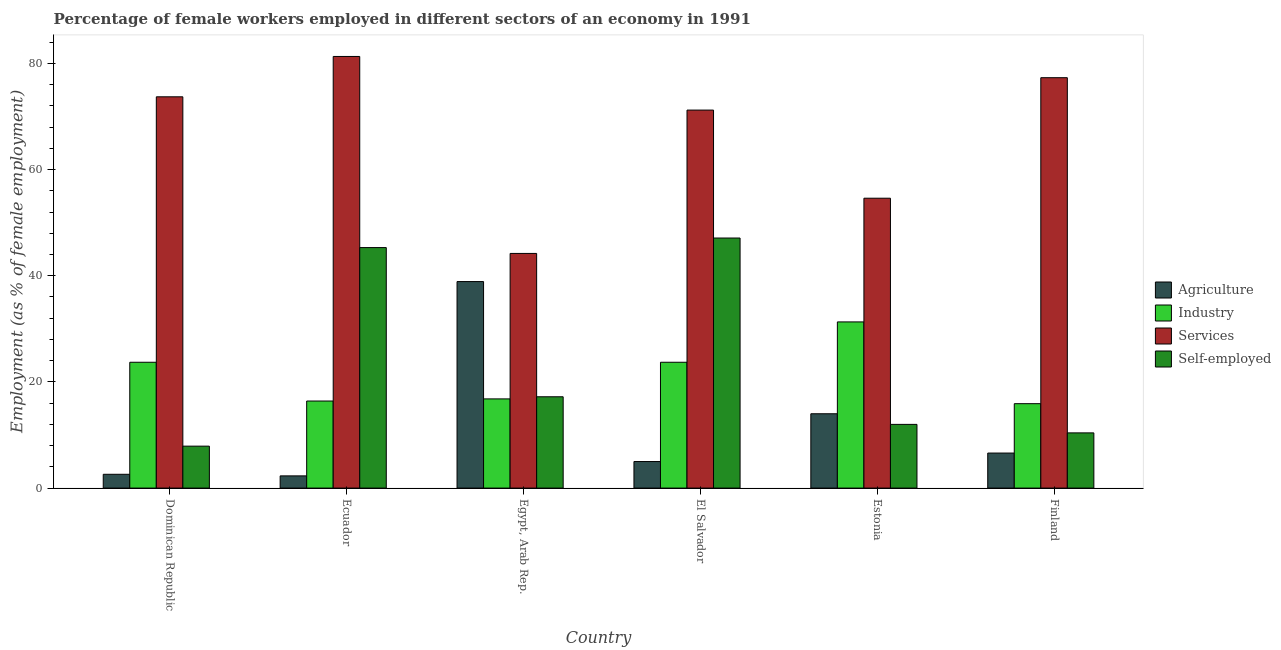How many different coloured bars are there?
Your answer should be compact. 4. How many groups of bars are there?
Offer a very short reply. 6. How many bars are there on the 1st tick from the right?
Ensure brevity in your answer.  4. What is the label of the 3rd group of bars from the left?
Your answer should be very brief. Egypt, Arab Rep. What is the percentage of female workers in services in El Salvador?
Your answer should be compact. 71.2. Across all countries, what is the maximum percentage of self employed female workers?
Provide a short and direct response. 47.1. Across all countries, what is the minimum percentage of female workers in industry?
Your answer should be compact. 15.9. In which country was the percentage of female workers in services maximum?
Offer a terse response. Ecuador. In which country was the percentage of female workers in services minimum?
Your answer should be very brief. Egypt, Arab Rep. What is the total percentage of female workers in services in the graph?
Provide a short and direct response. 402.3. What is the difference between the percentage of female workers in services in Ecuador and that in Finland?
Offer a terse response. 4. What is the difference between the percentage of self employed female workers in Estonia and the percentage of female workers in industry in Egypt, Arab Rep.?
Provide a succinct answer. -4.8. What is the average percentage of female workers in services per country?
Offer a terse response. 67.05. What is the difference between the percentage of female workers in services and percentage of female workers in agriculture in El Salvador?
Your answer should be very brief. 66.2. In how many countries, is the percentage of female workers in services greater than 72 %?
Offer a very short reply. 3. What is the ratio of the percentage of self employed female workers in Estonia to that in Finland?
Your answer should be very brief. 1.15. Is the percentage of female workers in agriculture in Egypt, Arab Rep. less than that in El Salvador?
Keep it short and to the point. No. Is the difference between the percentage of female workers in agriculture in Ecuador and Finland greater than the difference between the percentage of female workers in services in Ecuador and Finland?
Provide a short and direct response. No. What is the difference between the highest and the lowest percentage of self employed female workers?
Ensure brevity in your answer.  39.2. In how many countries, is the percentage of female workers in industry greater than the average percentage of female workers in industry taken over all countries?
Offer a very short reply. 3. What does the 3rd bar from the left in Dominican Republic represents?
Provide a succinct answer. Services. What does the 2nd bar from the right in Estonia represents?
Offer a terse response. Services. Is it the case that in every country, the sum of the percentage of female workers in agriculture and percentage of female workers in industry is greater than the percentage of female workers in services?
Provide a short and direct response. No. How many bars are there?
Provide a short and direct response. 24. Are all the bars in the graph horizontal?
Give a very brief answer. No. Does the graph contain grids?
Your response must be concise. No. Where does the legend appear in the graph?
Give a very brief answer. Center right. What is the title of the graph?
Offer a terse response. Percentage of female workers employed in different sectors of an economy in 1991. Does "Switzerland" appear as one of the legend labels in the graph?
Make the answer very short. No. What is the label or title of the X-axis?
Your response must be concise. Country. What is the label or title of the Y-axis?
Your answer should be very brief. Employment (as % of female employment). What is the Employment (as % of female employment) of Agriculture in Dominican Republic?
Make the answer very short. 2.6. What is the Employment (as % of female employment) in Industry in Dominican Republic?
Give a very brief answer. 23.7. What is the Employment (as % of female employment) of Services in Dominican Republic?
Provide a short and direct response. 73.7. What is the Employment (as % of female employment) of Self-employed in Dominican Republic?
Offer a terse response. 7.9. What is the Employment (as % of female employment) of Agriculture in Ecuador?
Your answer should be compact. 2.3. What is the Employment (as % of female employment) in Industry in Ecuador?
Offer a terse response. 16.4. What is the Employment (as % of female employment) in Services in Ecuador?
Your answer should be compact. 81.3. What is the Employment (as % of female employment) in Self-employed in Ecuador?
Offer a very short reply. 45.3. What is the Employment (as % of female employment) of Agriculture in Egypt, Arab Rep.?
Ensure brevity in your answer.  38.9. What is the Employment (as % of female employment) of Industry in Egypt, Arab Rep.?
Provide a short and direct response. 16.8. What is the Employment (as % of female employment) of Services in Egypt, Arab Rep.?
Your response must be concise. 44.2. What is the Employment (as % of female employment) of Self-employed in Egypt, Arab Rep.?
Keep it short and to the point. 17.2. What is the Employment (as % of female employment) of Industry in El Salvador?
Give a very brief answer. 23.7. What is the Employment (as % of female employment) in Services in El Salvador?
Your answer should be very brief. 71.2. What is the Employment (as % of female employment) of Self-employed in El Salvador?
Give a very brief answer. 47.1. What is the Employment (as % of female employment) of Industry in Estonia?
Provide a short and direct response. 31.3. What is the Employment (as % of female employment) in Services in Estonia?
Provide a short and direct response. 54.6. What is the Employment (as % of female employment) in Agriculture in Finland?
Keep it short and to the point. 6.6. What is the Employment (as % of female employment) in Industry in Finland?
Keep it short and to the point. 15.9. What is the Employment (as % of female employment) in Services in Finland?
Make the answer very short. 77.3. What is the Employment (as % of female employment) in Self-employed in Finland?
Provide a succinct answer. 10.4. Across all countries, what is the maximum Employment (as % of female employment) of Agriculture?
Ensure brevity in your answer.  38.9. Across all countries, what is the maximum Employment (as % of female employment) in Industry?
Ensure brevity in your answer.  31.3. Across all countries, what is the maximum Employment (as % of female employment) in Services?
Offer a terse response. 81.3. Across all countries, what is the maximum Employment (as % of female employment) in Self-employed?
Offer a terse response. 47.1. Across all countries, what is the minimum Employment (as % of female employment) in Agriculture?
Provide a succinct answer. 2.3. Across all countries, what is the minimum Employment (as % of female employment) in Industry?
Your answer should be very brief. 15.9. Across all countries, what is the minimum Employment (as % of female employment) in Services?
Your answer should be compact. 44.2. Across all countries, what is the minimum Employment (as % of female employment) of Self-employed?
Provide a short and direct response. 7.9. What is the total Employment (as % of female employment) of Agriculture in the graph?
Your answer should be compact. 69.4. What is the total Employment (as % of female employment) in Industry in the graph?
Provide a short and direct response. 127.8. What is the total Employment (as % of female employment) in Services in the graph?
Your response must be concise. 402.3. What is the total Employment (as % of female employment) of Self-employed in the graph?
Offer a terse response. 139.9. What is the difference between the Employment (as % of female employment) in Self-employed in Dominican Republic and that in Ecuador?
Your answer should be very brief. -37.4. What is the difference between the Employment (as % of female employment) in Agriculture in Dominican Republic and that in Egypt, Arab Rep.?
Your answer should be compact. -36.3. What is the difference between the Employment (as % of female employment) of Services in Dominican Republic and that in Egypt, Arab Rep.?
Provide a short and direct response. 29.5. What is the difference between the Employment (as % of female employment) in Agriculture in Dominican Republic and that in El Salvador?
Make the answer very short. -2.4. What is the difference between the Employment (as % of female employment) of Industry in Dominican Republic and that in El Salvador?
Ensure brevity in your answer.  0. What is the difference between the Employment (as % of female employment) in Self-employed in Dominican Republic and that in El Salvador?
Provide a short and direct response. -39.2. What is the difference between the Employment (as % of female employment) of Agriculture in Dominican Republic and that in Estonia?
Provide a short and direct response. -11.4. What is the difference between the Employment (as % of female employment) in Industry in Dominican Republic and that in Estonia?
Your answer should be compact. -7.6. What is the difference between the Employment (as % of female employment) of Services in Dominican Republic and that in Estonia?
Give a very brief answer. 19.1. What is the difference between the Employment (as % of female employment) in Self-employed in Dominican Republic and that in Estonia?
Your response must be concise. -4.1. What is the difference between the Employment (as % of female employment) in Agriculture in Dominican Republic and that in Finland?
Ensure brevity in your answer.  -4. What is the difference between the Employment (as % of female employment) of Self-employed in Dominican Republic and that in Finland?
Offer a very short reply. -2.5. What is the difference between the Employment (as % of female employment) of Agriculture in Ecuador and that in Egypt, Arab Rep.?
Offer a terse response. -36.6. What is the difference between the Employment (as % of female employment) of Industry in Ecuador and that in Egypt, Arab Rep.?
Provide a short and direct response. -0.4. What is the difference between the Employment (as % of female employment) in Services in Ecuador and that in Egypt, Arab Rep.?
Make the answer very short. 37.1. What is the difference between the Employment (as % of female employment) in Self-employed in Ecuador and that in Egypt, Arab Rep.?
Make the answer very short. 28.1. What is the difference between the Employment (as % of female employment) of Self-employed in Ecuador and that in El Salvador?
Your answer should be compact. -1.8. What is the difference between the Employment (as % of female employment) in Industry in Ecuador and that in Estonia?
Offer a very short reply. -14.9. What is the difference between the Employment (as % of female employment) of Services in Ecuador and that in Estonia?
Your answer should be compact. 26.7. What is the difference between the Employment (as % of female employment) in Self-employed in Ecuador and that in Estonia?
Give a very brief answer. 33.3. What is the difference between the Employment (as % of female employment) of Services in Ecuador and that in Finland?
Ensure brevity in your answer.  4. What is the difference between the Employment (as % of female employment) in Self-employed in Ecuador and that in Finland?
Make the answer very short. 34.9. What is the difference between the Employment (as % of female employment) in Agriculture in Egypt, Arab Rep. and that in El Salvador?
Provide a short and direct response. 33.9. What is the difference between the Employment (as % of female employment) in Industry in Egypt, Arab Rep. and that in El Salvador?
Give a very brief answer. -6.9. What is the difference between the Employment (as % of female employment) of Services in Egypt, Arab Rep. and that in El Salvador?
Offer a very short reply. -27. What is the difference between the Employment (as % of female employment) of Self-employed in Egypt, Arab Rep. and that in El Salvador?
Provide a short and direct response. -29.9. What is the difference between the Employment (as % of female employment) in Agriculture in Egypt, Arab Rep. and that in Estonia?
Your answer should be compact. 24.9. What is the difference between the Employment (as % of female employment) in Industry in Egypt, Arab Rep. and that in Estonia?
Your answer should be compact. -14.5. What is the difference between the Employment (as % of female employment) in Self-employed in Egypt, Arab Rep. and that in Estonia?
Give a very brief answer. 5.2. What is the difference between the Employment (as % of female employment) in Agriculture in Egypt, Arab Rep. and that in Finland?
Ensure brevity in your answer.  32.3. What is the difference between the Employment (as % of female employment) of Services in Egypt, Arab Rep. and that in Finland?
Your answer should be compact. -33.1. What is the difference between the Employment (as % of female employment) of Self-employed in Egypt, Arab Rep. and that in Finland?
Ensure brevity in your answer.  6.8. What is the difference between the Employment (as % of female employment) in Agriculture in El Salvador and that in Estonia?
Provide a short and direct response. -9. What is the difference between the Employment (as % of female employment) of Industry in El Salvador and that in Estonia?
Your answer should be compact. -7.6. What is the difference between the Employment (as % of female employment) in Services in El Salvador and that in Estonia?
Ensure brevity in your answer.  16.6. What is the difference between the Employment (as % of female employment) in Self-employed in El Salvador and that in Estonia?
Offer a terse response. 35.1. What is the difference between the Employment (as % of female employment) in Agriculture in El Salvador and that in Finland?
Provide a succinct answer. -1.6. What is the difference between the Employment (as % of female employment) in Industry in El Salvador and that in Finland?
Give a very brief answer. 7.8. What is the difference between the Employment (as % of female employment) of Services in El Salvador and that in Finland?
Provide a short and direct response. -6.1. What is the difference between the Employment (as % of female employment) of Self-employed in El Salvador and that in Finland?
Provide a short and direct response. 36.7. What is the difference between the Employment (as % of female employment) of Industry in Estonia and that in Finland?
Offer a terse response. 15.4. What is the difference between the Employment (as % of female employment) of Services in Estonia and that in Finland?
Your answer should be very brief. -22.7. What is the difference between the Employment (as % of female employment) of Agriculture in Dominican Republic and the Employment (as % of female employment) of Industry in Ecuador?
Offer a very short reply. -13.8. What is the difference between the Employment (as % of female employment) in Agriculture in Dominican Republic and the Employment (as % of female employment) in Services in Ecuador?
Your answer should be very brief. -78.7. What is the difference between the Employment (as % of female employment) of Agriculture in Dominican Republic and the Employment (as % of female employment) of Self-employed in Ecuador?
Make the answer very short. -42.7. What is the difference between the Employment (as % of female employment) in Industry in Dominican Republic and the Employment (as % of female employment) in Services in Ecuador?
Provide a short and direct response. -57.6. What is the difference between the Employment (as % of female employment) of Industry in Dominican Republic and the Employment (as % of female employment) of Self-employed in Ecuador?
Your response must be concise. -21.6. What is the difference between the Employment (as % of female employment) in Services in Dominican Republic and the Employment (as % of female employment) in Self-employed in Ecuador?
Keep it short and to the point. 28.4. What is the difference between the Employment (as % of female employment) of Agriculture in Dominican Republic and the Employment (as % of female employment) of Industry in Egypt, Arab Rep.?
Give a very brief answer. -14.2. What is the difference between the Employment (as % of female employment) of Agriculture in Dominican Republic and the Employment (as % of female employment) of Services in Egypt, Arab Rep.?
Make the answer very short. -41.6. What is the difference between the Employment (as % of female employment) of Agriculture in Dominican Republic and the Employment (as % of female employment) of Self-employed in Egypt, Arab Rep.?
Keep it short and to the point. -14.6. What is the difference between the Employment (as % of female employment) in Industry in Dominican Republic and the Employment (as % of female employment) in Services in Egypt, Arab Rep.?
Give a very brief answer. -20.5. What is the difference between the Employment (as % of female employment) in Industry in Dominican Republic and the Employment (as % of female employment) in Self-employed in Egypt, Arab Rep.?
Provide a succinct answer. 6.5. What is the difference between the Employment (as % of female employment) in Services in Dominican Republic and the Employment (as % of female employment) in Self-employed in Egypt, Arab Rep.?
Your response must be concise. 56.5. What is the difference between the Employment (as % of female employment) of Agriculture in Dominican Republic and the Employment (as % of female employment) of Industry in El Salvador?
Provide a short and direct response. -21.1. What is the difference between the Employment (as % of female employment) of Agriculture in Dominican Republic and the Employment (as % of female employment) of Services in El Salvador?
Keep it short and to the point. -68.6. What is the difference between the Employment (as % of female employment) of Agriculture in Dominican Republic and the Employment (as % of female employment) of Self-employed in El Salvador?
Your answer should be very brief. -44.5. What is the difference between the Employment (as % of female employment) in Industry in Dominican Republic and the Employment (as % of female employment) in Services in El Salvador?
Your response must be concise. -47.5. What is the difference between the Employment (as % of female employment) of Industry in Dominican Republic and the Employment (as % of female employment) of Self-employed in El Salvador?
Offer a very short reply. -23.4. What is the difference between the Employment (as % of female employment) of Services in Dominican Republic and the Employment (as % of female employment) of Self-employed in El Salvador?
Offer a very short reply. 26.6. What is the difference between the Employment (as % of female employment) of Agriculture in Dominican Republic and the Employment (as % of female employment) of Industry in Estonia?
Provide a short and direct response. -28.7. What is the difference between the Employment (as % of female employment) in Agriculture in Dominican Republic and the Employment (as % of female employment) in Services in Estonia?
Ensure brevity in your answer.  -52. What is the difference between the Employment (as % of female employment) in Industry in Dominican Republic and the Employment (as % of female employment) in Services in Estonia?
Your answer should be very brief. -30.9. What is the difference between the Employment (as % of female employment) of Industry in Dominican Republic and the Employment (as % of female employment) of Self-employed in Estonia?
Make the answer very short. 11.7. What is the difference between the Employment (as % of female employment) of Services in Dominican Republic and the Employment (as % of female employment) of Self-employed in Estonia?
Make the answer very short. 61.7. What is the difference between the Employment (as % of female employment) in Agriculture in Dominican Republic and the Employment (as % of female employment) in Industry in Finland?
Provide a short and direct response. -13.3. What is the difference between the Employment (as % of female employment) of Agriculture in Dominican Republic and the Employment (as % of female employment) of Services in Finland?
Your response must be concise. -74.7. What is the difference between the Employment (as % of female employment) of Agriculture in Dominican Republic and the Employment (as % of female employment) of Self-employed in Finland?
Your response must be concise. -7.8. What is the difference between the Employment (as % of female employment) in Industry in Dominican Republic and the Employment (as % of female employment) in Services in Finland?
Provide a short and direct response. -53.6. What is the difference between the Employment (as % of female employment) in Services in Dominican Republic and the Employment (as % of female employment) in Self-employed in Finland?
Offer a very short reply. 63.3. What is the difference between the Employment (as % of female employment) of Agriculture in Ecuador and the Employment (as % of female employment) of Services in Egypt, Arab Rep.?
Your response must be concise. -41.9. What is the difference between the Employment (as % of female employment) in Agriculture in Ecuador and the Employment (as % of female employment) in Self-employed in Egypt, Arab Rep.?
Keep it short and to the point. -14.9. What is the difference between the Employment (as % of female employment) of Industry in Ecuador and the Employment (as % of female employment) of Services in Egypt, Arab Rep.?
Keep it short and to the point. -27.8. What is the difference between the Employment (as % of female employment) of Services in Ecuador and the Employment (as % of female employment) of Self-employed in Egypt, Arab Rep.?
Ensure brevity in your answer.  64.1. What is the difference between the Employment (as % of female employment) of Agriculture in Ecuador and the Employment (as % of female employment) of Industry in El Salvador?
Your answer should be compact. -21.4. What is the difference between the Employment (as % of female employment) of Agriculture in Ecuador and the Employment (as % of female employment) of Services in El Salvador?
Your answer should be compact. -68.9. What is the difference between the Employment (as % of female employment) in Agriculture in Ecuador and the Employment (as % of female employment) in Self-employed in El Salvador?
Offer a terse response. -44.8. What is the difference between the Employment (as % of female employment) in Industry in Ecuador and the Employment (as % of female employment) in Services in El Salvador?
Keep it short and to the point. -54.8. What is the difference between the Employment (as % of female employment) of Industry in Ecuador and the Employment (as % of female employment) of Self-employed in El Salvador?
Your answer should be very brief. -30.7. What is the difference between the Employment (as % of female employment) in Services in Ecuador and the Employment (as % of female employment) in Self-employed in El Salvador?
Your answer should be very brief. 34.2. What is the difference between the Employment (as % of female employment) in Agriculture in Ecuador and the Employment (as % of female employment) in Services in Estonia?
Your answer should be very brief. -52.3. What is the difference between the Employment (as % of female employment) in Industry in Ecuador and the Employment (as % of female employment) in Services in Estonia?
Your answer should be very brief. -38.2. What is the difference between the Employment (as % of female employment) of Services in Ecuador and the Employment (as % of female employment) of Self-employed in Estonia?
Provide a succinct answer. 69.3. What is the difference between the Employment (as % of female employment) of Agriculture in Ecuador and the Employment (as % of female employment) of Industry in Finland?
Keep it short and to the point. -13.6. What is the difference between the Employment (as % of female employment) in Agriculture in Ecuador and the Employment (as % of female employment) in Services in Finland?
Provide a succinct answer. -75. What is the difference between the Employment (as % of female employment) of Agriculture in Ecuador and the Employment (as % of female employment) of Self-employed in Finland?
Provide a short and direct response. -8.1. What is the difference between the Employment (as % of female employment) in Industry in Ecuador and the Employment (as % of female employment) in Services in Finland?
Make the answer very short. -60.9. What is the difference between the Employment (as % of female employment) in Industry in Ecuador and the Employment (as % of female employment) in Self-employed in Finland?
Give a very brief answer. 6. What is the difference between the Employment (as % of female employment) of Services in Ecuador and the Employment (as % of female employment) of Self-employed in Finland?
Your answer should be compact. 70.9. What is the difference between the Employment (as % of female employment) in Agriculture in Egypt, Arab Rep. and the Employment (as % of female employment) in Industry in El Salvador?
Your response must be concise. 15.2. What is the difference between the Employment (as % of female employment) of Agriculture in Egypt, Arab Rep. and the Employment (as % of female employment) of Services in El Salvador?
Offer a terse response. -32.3. What is the difference between the Employment (as % of female employment) in Industry in Egypt, Arab Rep. and the Employment (as % of female employment) in Services in El Salvador?
Ensure brevity in your answer.  -54.4. What is the difference between the Employment (as % of female employment) in Industry in Egypt, Arab Rep. and the Employment (as % of female employment) in Self-employed in El Salvador?
Provide a short and direct response. -30.3. What is the difference between the Employment (as % of female employment) of Agriculture in Egypt, Arab Rep. and the Employment (as % of female employment) of Industry in Estonia?
Your answer should be compact. 7.6. What is the difference between the Employment (as % of female employment) of Agriculture in Egypt, Arab Rep. and the Employment (as % of female employment) of Services in Estonia?
Your response must be concise. -15.7. What is the difference between the Employment (as % of female employment) in Agriculture in Egypt, Arab Rep. and the Employment (as % of female employment) in Self-employed in Estonia?
Provide a succinct answer. 26.9. What is the difference between the Employment (as % of female employment) in Industry in Egypt, Arab Rep. and the Employment (as % of female employment) in Services in Estonia?
Offer a very short reply. -37.8. What is the difference between the Employment (as % of female employment) of Services in Egypt, Arab Rep. and the Employment (as % of female employment) of Self-employed in Estonia?
Your answer should be compact. 32.2. What is the difference between the Employment (as % of female employment) of Agriculture in Egypt, Arab Rep. and the Employment (as % of female employment) of Services in Finland?
Keep it short and to the point. -38.4. What is the difference between the Employment (as % of female employment) in Industry in Egypt, Arab Rep. and the Employment (as % of female employment) in Services in Finland?
Provide a short and direct response. -60.5. What is the difference between the Employment (as % of female employment) of Industry in Egypt, Arab Rep. and the Employment (as % of female employment) of Self-employed in Finland?
Ensure brevity in your answer.  6.4. What is the difference between the Employment (as % of female employment) in Services in Egypt, Arab Rep. and the Employment (as % of female employment) in Self-employed in Finland?
Your response must be concise. 33.8. What is the difference between the Employment (as % of female employment) of Agriculture in El Salvador and the Employment (as % of female employment) of Industry in Estonia?
Your answer should be compact. -26.3. What is the difference between the Employment (as % of female employment) in Agriculture in El Salvador and the Employment (as % of female employment) in Services in Estonia?
Your answer should be compact. -49.6. What is the difference between the Employment (as % of female employment) of Agriculture in El Salvador and the Employment (as % of female employment) of Self-employed in Estonia?
Offer a very short reply. -7. What is the difference between the Employment (as % of female employment) in Industry in El Salvador and the Employment (as % of female employment) in Services in Estonia?
Your response must be concise. -30.9. What is the difference between the Employment (as % of female employment) of Services in El Salvador and the Employment (as % of female employment) of Self-employed in Estonia?
Ensure brevity in your answer.  59.2. What is the difference between the Employment (as % of female employment) of Agriculture in El Salvador and the Employment (as % of female employment) of Services in Finland?
Ensure brevity in your answer.  -72.3. What is the difference between the Employment (as % of female employment) in Industry in El Salvador and the Employment (as % of female employment) in Services in Finland?
Keep it short and to the point. -53.6. What is the difference between the Employment (as % of female employment) of Industry in El Salvador and the Employment (as % of female employment) of Self-employed in Finland?
Your answer should be compact. 13.3. What is the difference between the Employment (as % of female employment) of Services in El Salvador and the Employment (as % of female employment) of Self-employed in Finland?
Your answer should be very brief. 60.8. What is the difference between the Employment (as % of female employment) in Agriculture in Estonia and the Employment (as % of female employment) in Services in Finland?
Offer a very short reply. -63.3. What is the difference between the Employment (as % of female employment) of Agriculture in Estonia and the Employment (as % of female employment) of Self-employed in Finland?
Your response must be concise. 3.6. What is the difference between the Employment (as % of female employment) of Industry in Estonia and the Employment (as % of female employment) of Services in Finland?
Your answer should be very brief. -46. What is the difference between the Employment (as % of female employment) of Industry in Estonia and the Employment (as % of female employment) of Self-employed in Finland?
Make the answer very short. 20.9. What is the difference between the Employment (as % of female employment) of Services in Estonia and the Employment (as % of female employment) of Self-employed in Finland?
Ensure brevity in your answer.  44.2. What is the average Employment (as % of female employment) of Agriculture per country?
Provide a succinct answer. 11.57. What is the average Employment (as % of female employment) of Industry per country?
Keep it short and to the point. 21.3. What is the average Employment (as % of female employment) of Services per country?
Make the answer very short. 67.05. What is the average Employment (as % of female employment) in Self-employed per country?
Offer a terse response. 23.32. What is the difference between the Employment (as % of female employment) in Agriculture and Employment (as % of female employment) in Industry in Dominican Republic?
Ensure brevity in your answer.  -21.1. What is the difference between the Employment (as % of female employment) of Agriculture and Employment (as % of female employment) of Services in Dominican Republic?
Give a very brief answer. -71.1. What is the difference between the Employment (as % of female employment) in Agriculture and Employment (as % of female employment) in Self-employed in Dominican Republic?
Keep it short and to the point. -5.3. What is the difference between the Employment (as % of female employment) of Industry and Employment (as % of female employment) of Services in Dominican Republic?
Provide a succinct answer. -50. What is the difference between the Employment (as % of female employment) in Services and Employment (as % of female employment) in Self-employed in Dominican Republic?
Make the answer very short. 65.8. What is the difference between the Employment (as % of female employment) in Agriculture and Employment (as % of female employment) in Industry in Ecuador?
Keep it short and to the point. -14.1. What is the difference between the Employment (as % of female employment) of Agriculture and Employment (as % of female employment) of Services in Ecuador?
Provide a short and direct response. -79. What is the difference between the Employment (as % of female employment) of Agriculture and Employment (as % of female employment) of Self-employed in Ecuador?
Provide a short and direct response. -43. What is the difference between the Employment (as % of female employment) of Industry and Employment (as % of female employment) of Services in Ecuador?
Your response must be concise. -64.9. What is the difference between the Employment (as % of female employment) of Industry and Employment (as % of female employment) of Self-employed in Ecuador?
Give a very brief answer. -28.9. What is the difference between the Employment (as % of female employment) in Agriculture and Employment (as % of female employment) in Industry in Egypt, Arab Rep.?
Make the answer very short. 22.1. What is the difference between the Employment (as % of female employment) of Agriculture and Employment (as % of female employment) of Self-employed in Egypt, Arab Rep.?
Offer a very short reply. 21.7. What is the difference between the Employment (as % of female employment) in Industry and Employment (as % of female employment) in Services in Egypt, Arab Rep.?
Offer a very short reply. -27.4. What is the difference between the Employment (as % of female employment) in Industry and Employment (as % of female employment) in Self-employed in Egypt, Arab Rep.?
Provide a short and direct response. -0.4. What is the difference between the Employment (as % of female employment) of Agriculture and Employment (as % of female employment) of Industry in El Salvador?
Offer a terse response. -18.7. What is the difference between the Employment (as % of female employment) of Agriculture and Employment (as % of female employment) of Services in El Salvador?
Give a very brief answer. -66.2. What is the difference between the Employment (as % of female employment) in Agriculture and Employment (as % of female employment) in Self-employed in El Salvador?
Your answer should be compact. -42.1. What is the difference between the Employment (as % of female employment) in Industry and Employment (as % of female employment) in Services in El Salvador?
Provide a succinct answer. -47.5. What is the difference between the Employment (as % of female employment) of Industry and Employment (as % of female employment) of Self-employed in El Salvador?
Your answer should be very brief. -23.4. What is the difference between the Employment (as % of female employment) of Services and Employment (as % of female employment) of Self-employed in El Salvador?
Your answer should be compact. 24.1. What is the difference between the Employment (as % of female employment) of Agriculture and Employment (as % of female employment) of Industry in Estonia?
Offer a terse response. -17.3. What is the difference between the Employment (as % of female employment) in Agriculture and Employment (as % of female employment) in Services in Estonia?
Your answer should be compact. -40.6. What is the difference between the Employment (as % of female employment) of Agriculture and Employment (as % of female employment) of Self-employed in Estonia?
Provide a short and direct response. 2. What is the difference between the Employment (as % of female employment) of Industry and Employment (as % of female employment) of Services in Estonia?
Your answer should be very brief. -23.3. What is the difference between the Employment (as % of female employment) of Industry and Employment (as % of female employment) of Self-employed in Estonia?
Keep it short and to the point. 19.3. What is the difference between the Employment (as % of female employment) in Services and Employment (as % of female employment) in Self-employed in Estonia?
Give a very brief answer. 42.6. What is the difference between the Employment (as % of female employment) in Agriculture and Employment (as % of female employment) in Industry in Finland?
Offer a terse response. -9.3. What is the difference between the Employment (as % of female employment) of Agriculture and Employment (as % of female employment) of Services in Finland?
Your answer should be very brief. -70.7. What is the difference between the Employment (as % of female employment) of Industry and Employment (as % of female employment) of Services in Finland?
Your response must be concise. -61.4. What is the difference between the Employment (as % of female employment) of Services and Employment (as % of female employment) of Self-employed in Finland?
Offer a very short reply. 66.9. What is the ratio of the Employment (as % of female employment) in Agriculture in Dominican Republic to that in Ecuador?
Your response must be concise. 1.13. What is the ratio of the Employment (as % of female employment) in Industry in Dominican Republic to that in Ecuador?
Give a very brief answer. 1.45. What is the ratio of the Employment (as % of female employment) in Services in Dominican Republic to that in Ecuador?
Your response must be concise. 0.91. What is the ratio of the Employment (as % of female employment) in Self-employed in Dominican Republic to that in Ecuador?
Provide a short and direct response. 0.17. What is the ratio of the Employment (as % of female employment) in Agriculture in Dominican Republic to that in Egypt, Arab Rep.?
Offer a very short reply. 0.07. What is the ratio of the Employment (as % of female employment) in Industry in Dominican Republic to that in Egypt, Arab Rep.?
Keep it short and to the point. 1.41. What is the ratio of the Employment (as % of female employment) of Services in Dominican Republic to that in Egypt, Arab Rep.?
Keep it short and to the point. 1.67. What is the ratio of the Employment (as % of female employment) in Self-employed in Dominican Republic to that in Egypt, Arab Rep.?
Give a very brief answer. 0.46. What is the ratio of the Employment (as % of female employment) in Agriculture in Dominican Republic to that in El Salvador?
Your response must be concise. 0.52. What is the ratio of the Employment (as % of female employment) of Services in Dominican Republic to that in El Salvador?
Your answer should be very brief. 1.04. What is the ratio of the Employment (as % of female employment) in Self-employed in Dominican Republic to that in El Salvador?
Your response must be concise. 0.17. What is the ratio of the Employment (as % of female employment) of Agriculture in Dominican Republic to that in Estonia?
Provide a succinct answer. 0.19. What is the ratio of the Employment (as % of female employment) in Industry in Dominican Republic to that in Estonia?
Make the answer very short. 0.76. What is the ratio of the Employment (as % of female employment) of Services in Dominican Republic to that in Estonia?
Ensure brevity in your answer.  1.35. What is the ratio of the Employment (as % of female employment) in Self-employed in Dominican Republic to that in Estonia?
Provide a short and direct response. 0.66. What is the ratio of the Employment (as % of female employment) of Agriculture in Dominican Republic to that in Finland?
Your answer should be compact. 0.39. What is the ratio of the Employment (as % of female employment) in Industry in Dominican Republic to that in Finland?
Keep it short and to the point. 1.49. What is the ratio of the Employment (as % of female employment) of Services in Dominican Republic to that in Finland?
Keep it short and to the point. 0.95. What is the ratio of the Employment (as % of female employment) of Self-employed in Dominican Republic to that in Finland?
Offer a terse response. 0.76. What is the ratio of the Employment (as % of female employment) of Agriculture in Ecuador to that in Egypt, Arab Rep.?
Your answer should be compact. 0.06. What is the ratio of the Employment (as % of female employment) of Industry in Ecuador to that in Egypt, Arab Rep.?
Make the answer very short. 0.98. What is the ratio of the Employment (as % of female employment) of Services in Ecuador to that in Egypt, Arab Rep.?
Keep it short and to the point. 1.84. What is the ratio of the Employment (as % of female employment) of Self-employed in Ecuador to that in Egypt, Arab Rep.?
Give a very brief answer. 2.63. What is the ratio of the Employment (as % of female employment) of Agriculture in Ecuador to that in El Salvador?
Make the answer very short. 0.46. What is the ratio of the Employment (as % of female employment) of Industry in Ecuador to that in El Salvador?
Ensure brevity in your answer.  0.69. What is the ratio of the Employment (as % of female employment) of Services in Ecuador to that in El Salvador?
Keep it short and to the point. 1.14. What is the ratio of the Employment (as % of female employment) in Self-employed in Ecuador to that in El Salvador?
Ensure brevity in your answer.  0.96. What is the ratio of the Employment (as % of female employment) of Agriculture in Ecuador to that in Estonia?
Ensure brevity in your answer.  0.16. What is the ratio of the Employment (as % of female employment) of Industry in Ecuador to that in Estonia?
Your answer should be compact. 0.52. What is the ratio of the Employment (as % of female employment) of Services in Ecuador to that in Estonia?
Your answer should be very brief. 1.49. What is the ratio of the Employment (as % of female employment) in Self-employed in Ecuador to that in Estonia?
Give a very brief answer. 3.77. What is the ratio of the Employment (as % of female employment) of Agriculture in Ecuador to that in Finland?
Your response must be concise. 0.35. What is the ratio of the Employment (as % of female employment) in Industry in Ecuador to that in Finland?
Your answer should be very brief. 1.03. What is the ratio of the Employment (as % of female employment) in Services in Ecuador to that in Finland?
Your response must be concise. 1.05. What is the ratio of the Employment (as % of female employment) of Self-employed in Ecuador to that in Finland?
Give a very brief answer. 4.36. What is the ratio of the Employment (as % of female employment) of Agriculture in Egypt, Arab Rep. to that in El Salvador?
Offer a terse response. 7.78. What is the ratio of the Employment (as % of female employment) of Industry in Egypt, Arab Rep. to that in El Salvador?
Keep it short and to the point. 0.71. What is the ratio of the Employment (as % of female employment) in Services in Egypt, Arab Rep. to that in El Salvador?
Ensure brevity in your answer.  0.62. What is the ratio of the Employment (as % of female employment) of Self-employed in Egypt, Arab Rep. to that in El Salvador?
Keep it short and to the point. 0.37. What is the ratio of the Employment (as % of female employment) of Agriculture in Egypt, Arab Rep. to that in Estonia?
Keep it short and to the point. 2.78. What is the ratio of the Employment (as % of female employment) in Industry in Egypt, Arab Rep. to that in Estonia?
Give a very brief answer. 0.54. What is the ratio of the Employment (as % of female employment) of Services in Egypt, Arab Rep. to that in Estonia?
Give a very brief answer. 0.81. What is the ratio of the Employment (as % of female employment) of Self-employed in Egypt, Arab Rep. to that in Estonia?
Provide a short and direct response. 1.43. What is the ratio of the Employment (as % of female employment) in Agriculture in Egypt, Arab Rep. to that in Finland?
Your answer should be compact. 5.89. What is the ratio of the Employment (as % of female employment) in Industry in Egypt, Arab Rep. to that in Finland?
Give a very brief answer. 1.06. What is the ratio of the Employment (as % of female employment) in Services in Egypt, Arab Rep. to that in Finland?
Offer a very short reply. 0.57. What is the ratio of the Employment (as % of female employment) of Self-employed in Egypt, Arab Rep. to that in Finland?
Your answer should be very brief. 1.65. What is the ratio of the Employment (as % of female employment) in Agriculture in El Salvador to that in Estonia?
Your answer should be compact. 0.36. What is the ratio of the Employment (as % of female employment) of Industry in El Salvador to that in Estonia?
Your response must be concise. 0.76. What is the ratio of the Employment (as % of female employment) of Services in El Salvador to that in Estonia?
Keep it short and to the point. 1.3. What is the ratio of the Employment (as % of female employment) in Self-employed in El Salvador to that in Estonia?
Provide a succinct answer. 3.92. What is the ratio of the Employment (as % of female employment) of Agriculture in El Salvador to that in Finland?
Your answer should be compact. 0.76. What is the ratio of the Employment (as % of female employment) in Industry in El Salvador to that in Finland?
Ensure brevity in your answer.  1.49. What is the ratio of the Employment (as % of female employment) in Services in El Salvador to that in Finland?
Offer a very short reply. 0.92. What is the ratio of the Employment (as % of female employment) of Self-employed in El Salvador to that in Finland?
Your response must be concise. 4.53. What is the ratio of the Employment (as % of female employment) of Agriculture in Estonia to that in Finland?
Your answer should be compact. 2.12. What is the ratio of the Employment (as % of female employment) of Industry in Estonia to that in Finland?
Keep it short and to the point. 1.97. What is the ratio of the Employment (as % of female employment) of Services in Estonia to that in Finland?
Ensure brevity in your answer.  0.71. What is the ratio of the Employment (as % of female employment) of Self-employed in Estonia to that in Finland?
Provide a short and direct response. 1.15. What is the difference between the highest and the second highest Employment (as % of female employment) of Agriculture?
Your answer should be compact. 24.9. What is the difference between the highest and the lowest Employment (as % of female employment) of Agriculture?
Your answer should be very brief. 36.6. What is the difference between the highest and the lowest Employment (as % of female employment) in Services?
Offer a very short reply. 37.1. What is the difference between the highest and the lowest Employment (as % of female employment) in Self-employed?
Keep it short and to the point. 39.2. 